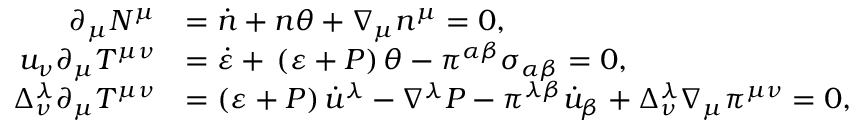<formula> <loc_0><loc_0><loc_500><loc_500>\begin{array} { r l } { \partial _ { \mu } N ^ { \mu } } & { = \dot { n } + n \theta + \nabla _ { \mu } n ^ { \mu } = 0 , } \\ { u _ { \nu } \partial _ { \mu } T ^ { \mu \nu } } & { = \dot { \varepsilon } + \, \left ( \varepsilon + P \right ) \theta - \pi ^ { \alpha \beta } \sigma _ { \alpha \beta } = 0 , } \\ { \Delta _ { \nu } ^ { \lambda } \partial _ { \mu } T ^ { \mu \nu } } & { = \left ( \varepsilon + P \right ) \dot { u } ^ { \lambda } - \nabla ^ { \lambda } P - \pi ^ { \lambda \beta } \dot { u } _ { \beta } + \Delta _ { \nu } ^ { \lambda } \nabla _ { \mu } \pi ^ { \mu \nu } = 0 , } \end{array}</formula> 